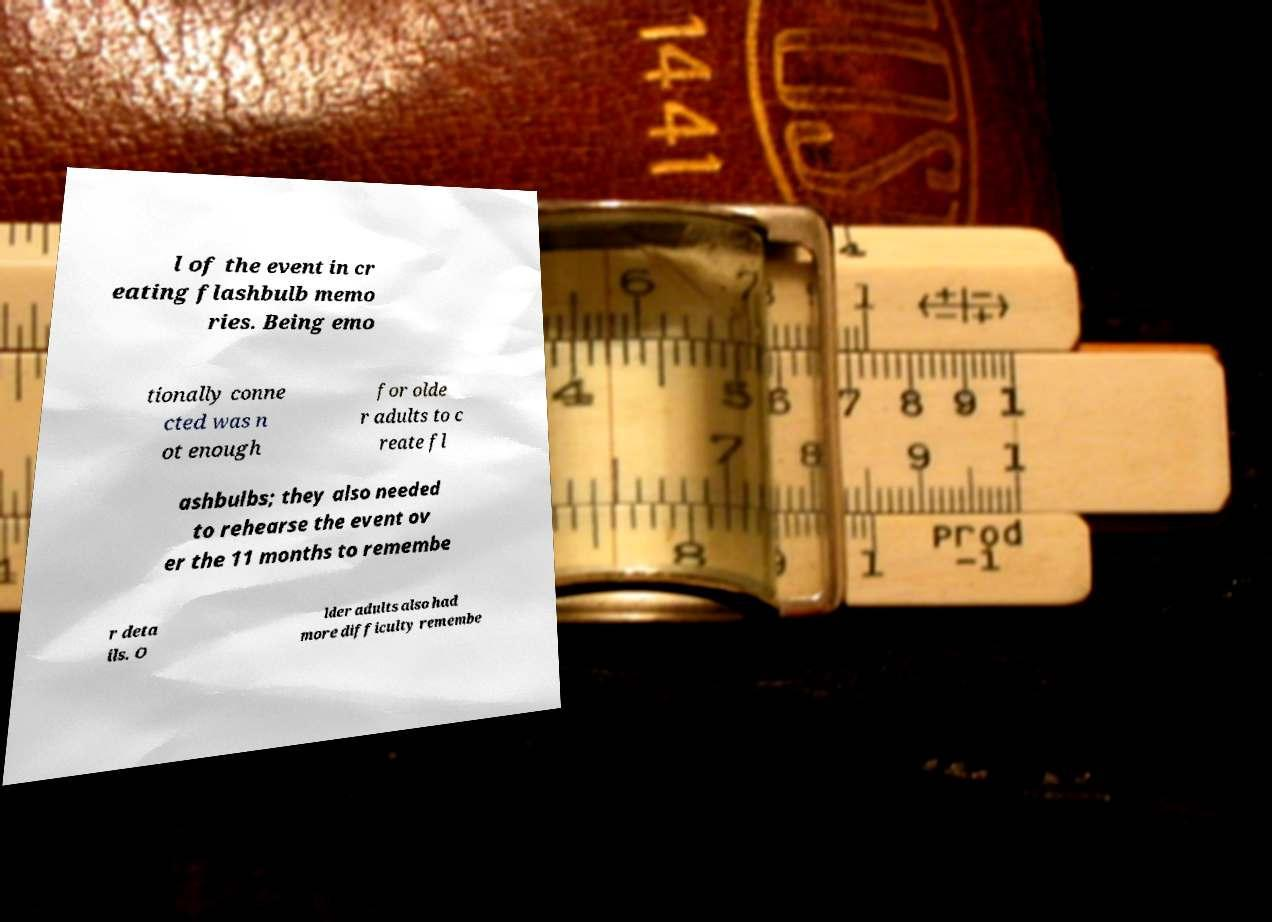Could you extract and type out the text from this image? l of the event in cr eating flashbulb memo ries. Being emo tionally conne cted was n ot enough for olde r adults to c reate fl ashbulbs; they also needed to rehearse the event ov er the 11 months to remembe r deta ils. O lder adults also had more difficulty remembe 